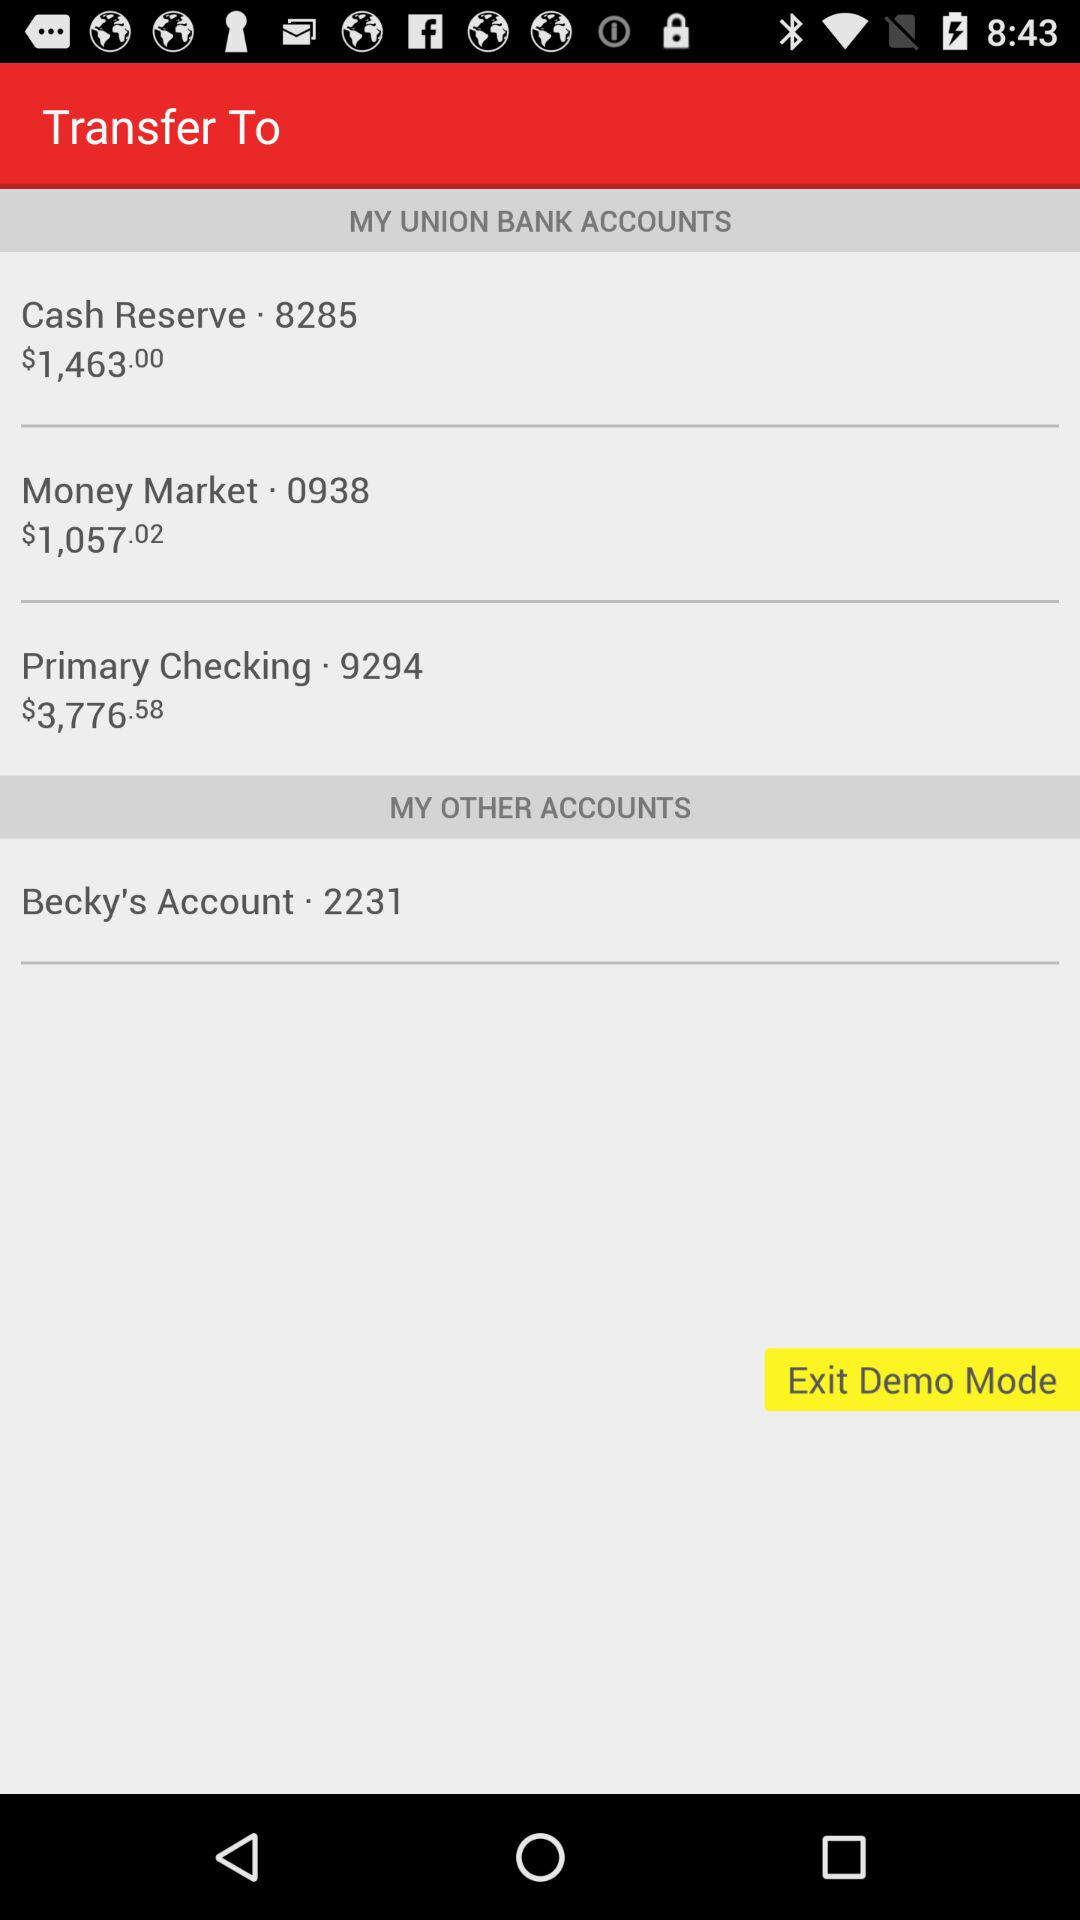What is the amount in the money market? The amount in the money market is $1,057.02. 